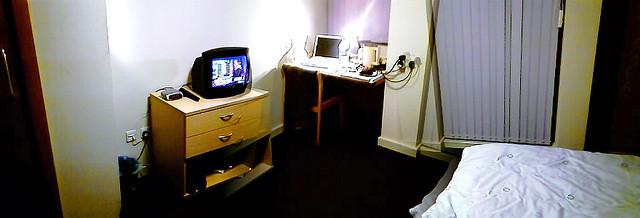Are the shades closed?
Be succinct. Yes. Is the TV on?
Concise answer only. Yes. What size is the TV screen?
Answer briefly. Small. 